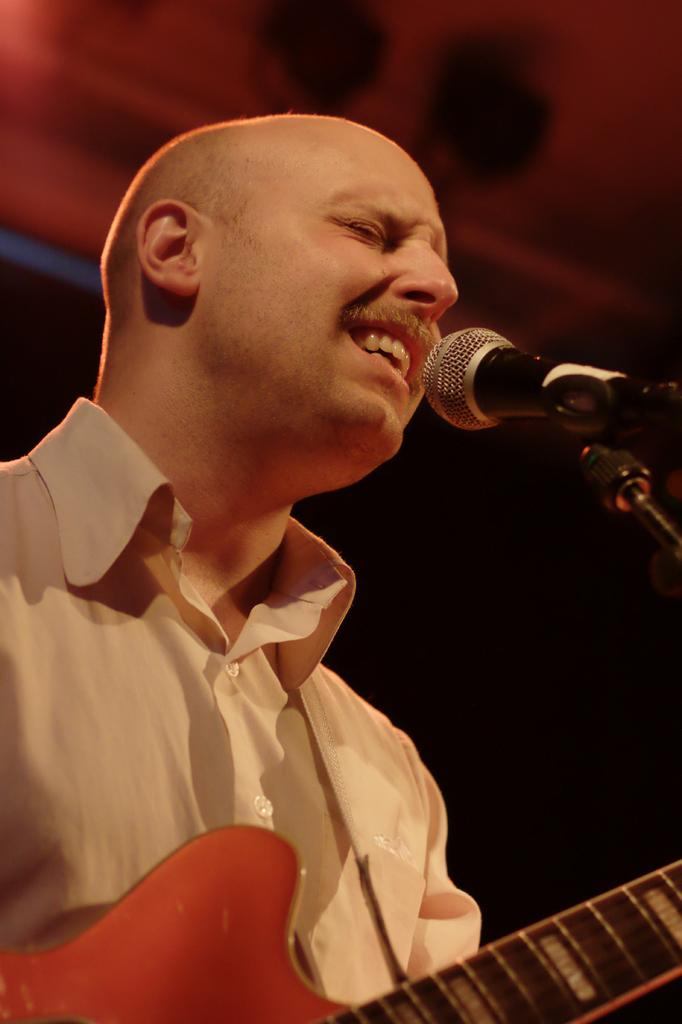What is the person in the image doing? The person is playing a guitar and singing. What is the person wearing in the image? The person is wearing a white shirt. What object is the person standing in front of? The person is standing in front of a microphone. What type of thread is being used to sew the word on the person's shirt in the image? There is no word or thread visible on the person's shirt in the image. 